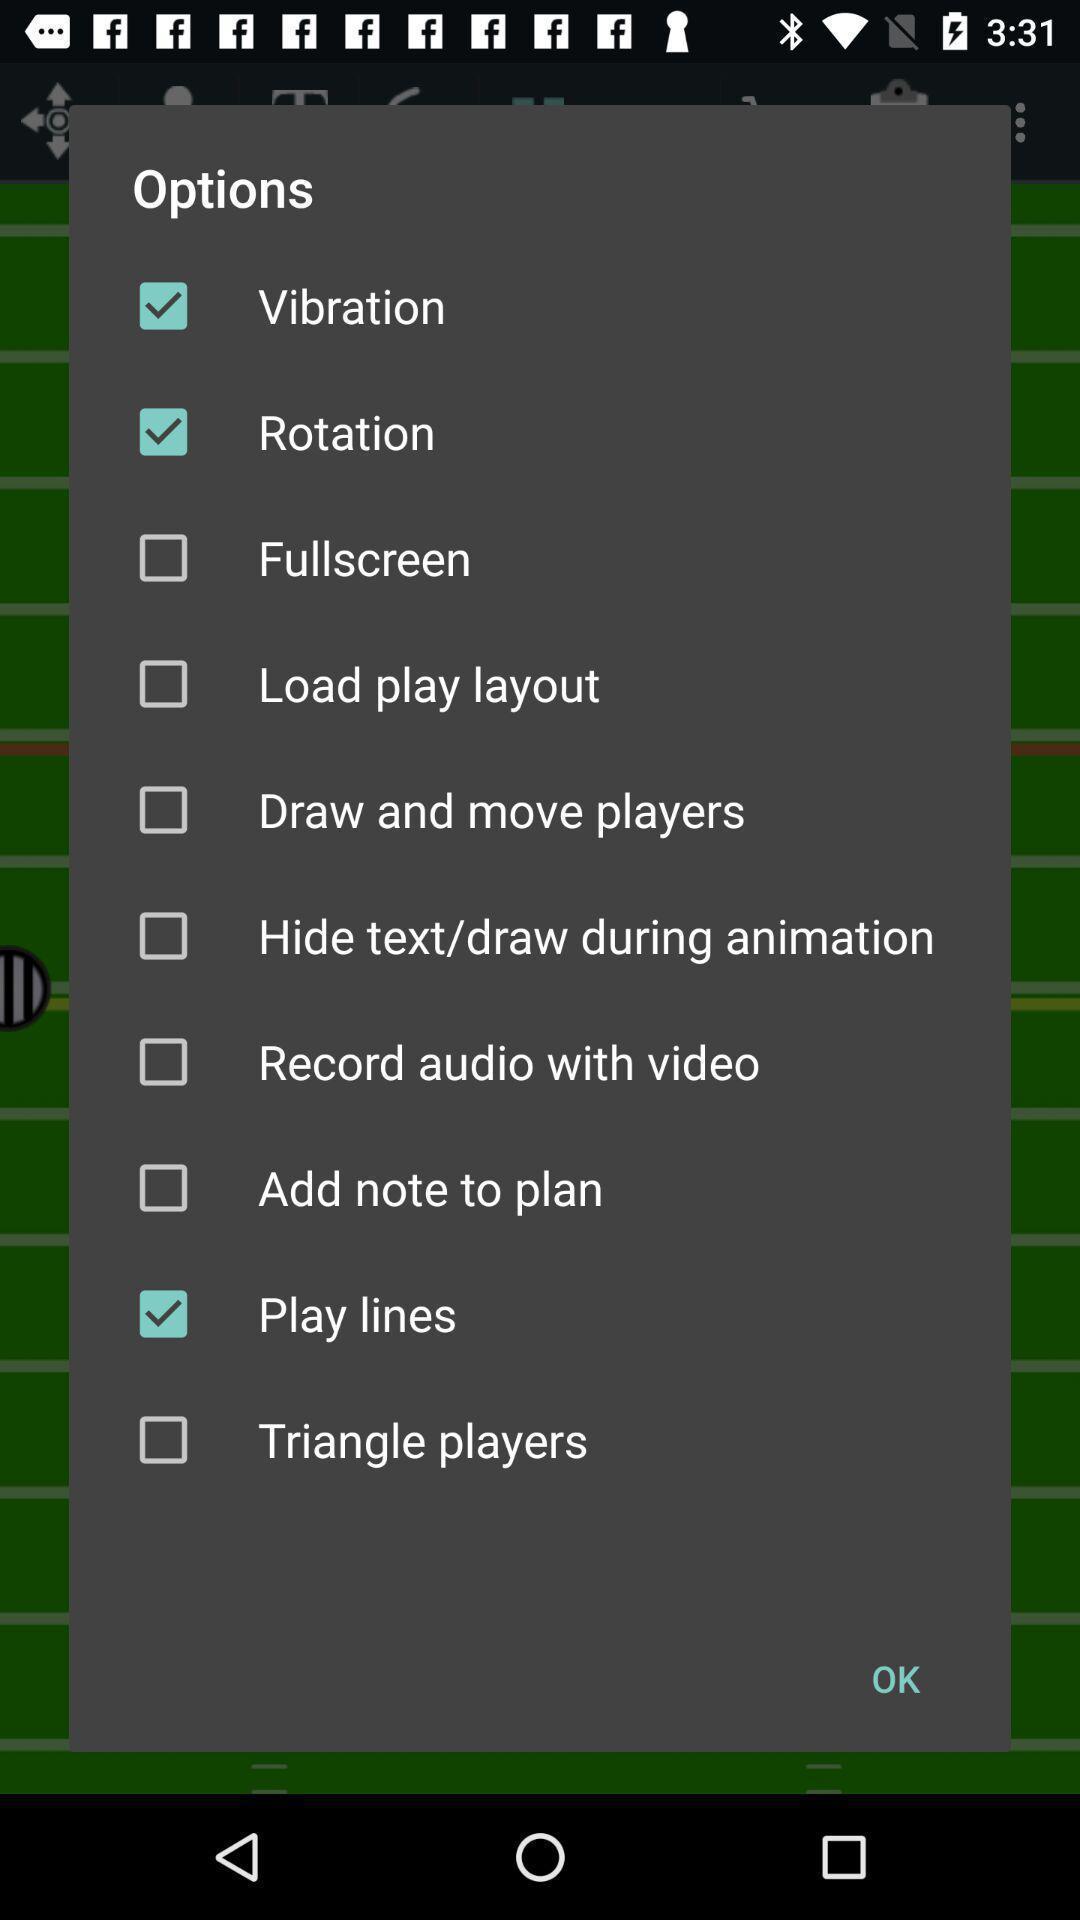What details can you identify in this image? Popup of various kinds of options to regulate the application. 